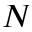<formula> <loc_0><loc_0><loc_500><loc_500>N</formula> 